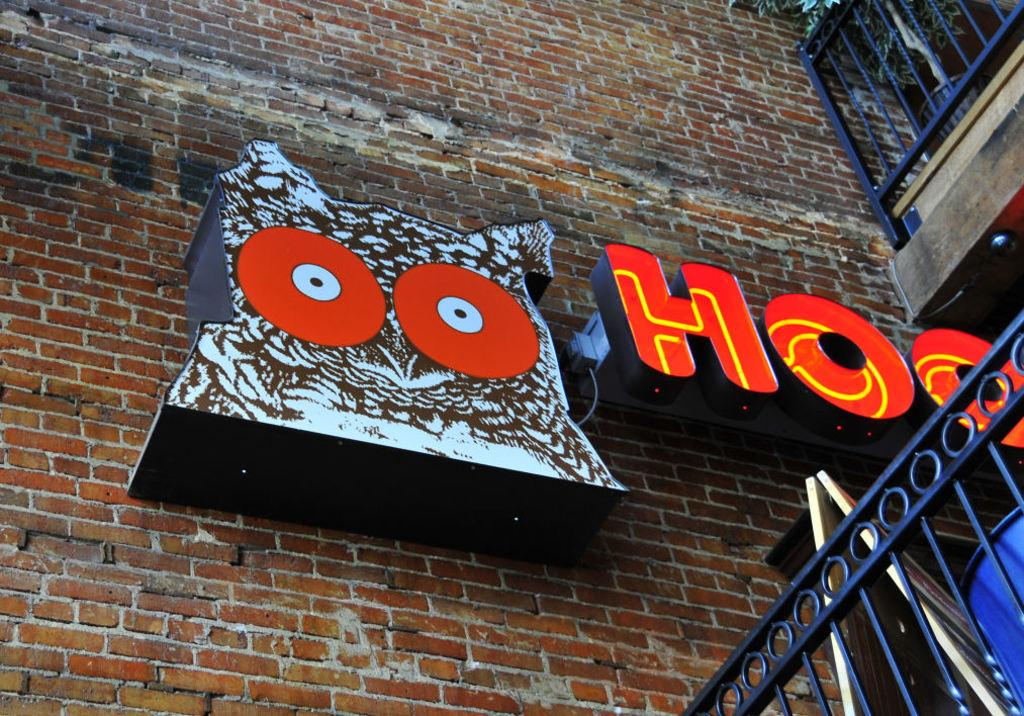Provide a one-sentence caption for the provided image. The sign on the exterior of this brick building indicates it is a Hooters restaurant. 